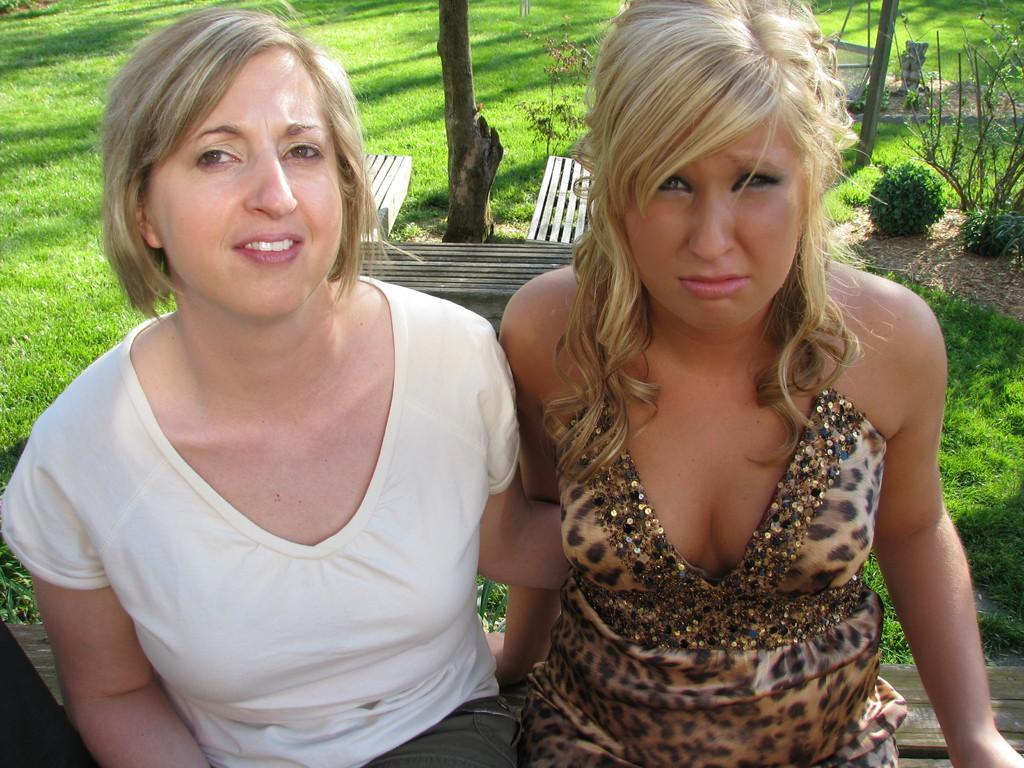Describe this image in one or two sentences. In the center of the image, we can see two ladies sitting on the bench and in the background, there is a tree trunk and we can see an other bench and there is a pole and we can see some plants. At the bottom, there is ground covered with grass. 